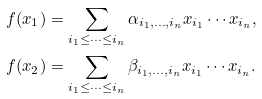<formula> <loc_0><loc_0><loc_500><loc_500>f ( x _ { 1 } ) & = \sum _ { i _ { 1 } \leq \cdots \leq i _ { n } } \alpha _ { i _ { 1 } , \dots , i _ { n } } x _ { i _ { 1 } } \cdots x _ { i _ { n } } , \\ f ( x _ { 2 } ) & = \sum _ { i _ { 1 } \leq \cdots \leq i _ { n } } \beta _ { i _ { 1 } , \dots , i _ { n } } x _ { i _ { 1 } } \cdots x _ { i _ { n } } .</formula> 